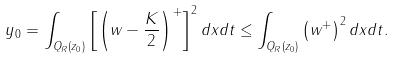<formula> <loc_0><loc_0><loc_500><loc_500>y _ { 0 } = \int _ { Q _ { R } ( z _ { 0 } ) } \left [ \left ( w - \frac { K } { 2 } \right ) ^ { + } \right ] ^ { 2 } d x d t \leq \int _ { Q _ { R } ( z _ { 0 } ) } \left ( w ^ { + } \right ) ^ { 2 } d x d t .</formula> 